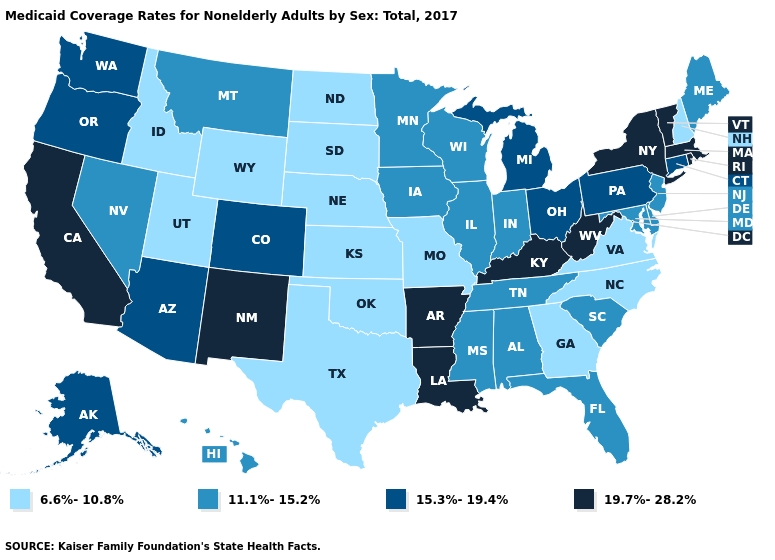What is the highest value in states that border Rhode Island?
Quick response, please. 19.7%-28.2%. Does the map have missing data?
Answer briefly. No. Does Oklahoma have the same value as Idaho?
Short answer required. Yes. Name the states that have a value in the range 19.7%-28.2%?
Be succinct. Arkansas, California, Kentucky, Louisiana, Massachusetts, New Mexico, New York, Rhode Island, Vermont, West Virginia. Which states have the lowest value in the USA?
Short answer required. Georgia, Idaho, Kansas, Missouri, Nebraska, New Hampshire, North Carolina, North Dakota, Oklahoma, South Dakota, Texas, Utah, Virginia, Wyoming. What is the value of Utah?
Give a very brief answer. 6.6%-10.8%. Name the states that have a value in the range 19.7%-28.2%?
Write a very short answer. Arkansas, California, Kentucky, Louisiana, Massachusetts, New Mexico, New York, Rhode Island, Vermont, West Virginia. What is the value of Ohio?
Quick response, please. 15.3%-19.4%. What is the highest value in the USA?
Keep it brief. 19.7%-28.2%. Name the states that have a value in the range 6.6%-10.8%?
Keep it brief. Georgia, Idaho, Kansas, Missouri, Nebraska, New Hampshire, North Carolina, North Dakota, Oklahoma, South Dakota, Texas, Utah, Virginia, Wyoming. Among the states that border Oregon , does California have the highest value?
Be succinct. Yes. What is the value of Hawaii?
Answer briefly. 11.1%-15.2%. What is the value of Pennsylvania?
Write a very short answer. 15.3%-19.4%. Which states hav the highest value in the Northeast?
Answer briefly. Massachusetts, New York, Rhode Island, Vermont. What is the highest value in the USA?
Answer briefly. 19.7%-28.2%. 